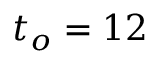<formula> <loc_0><loc_0><loc_500><loc_500>t _ { o } = 1 2</formula> 